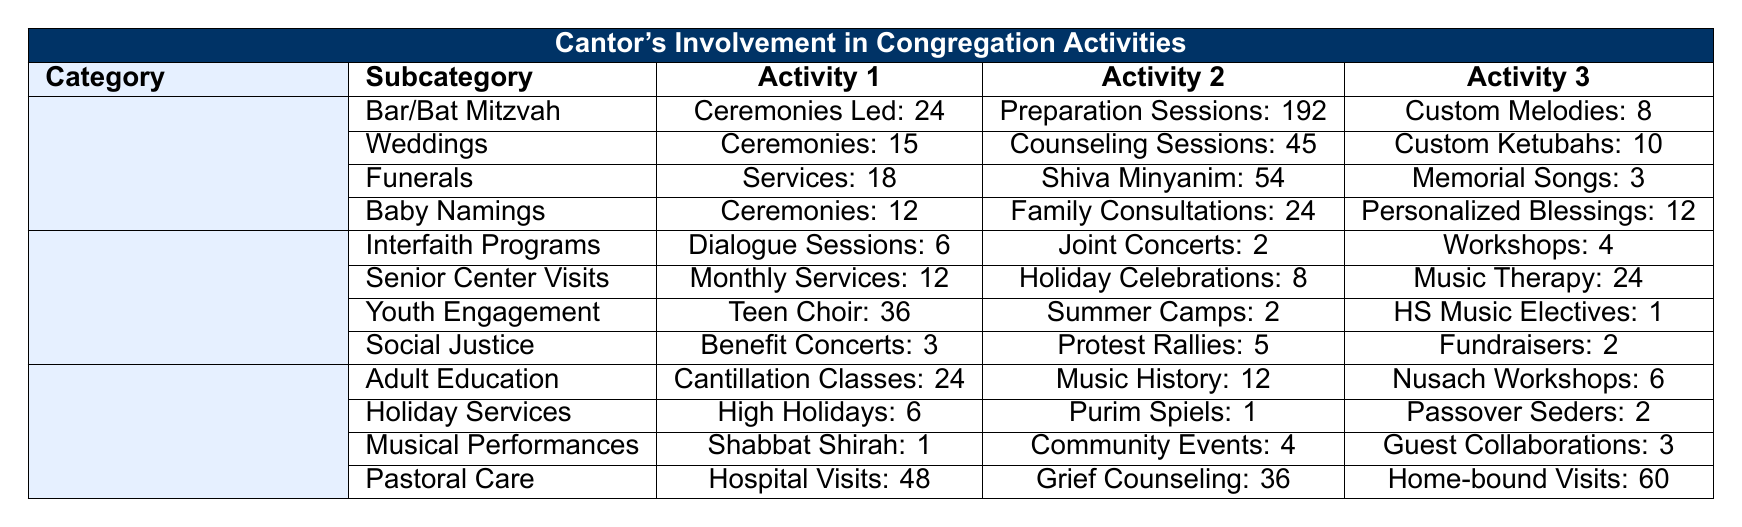What is the total number of Bar/Bat Mitzvah preparation sessions led by the cantor? The table states that there were 192 preparation sessions for Bar/Bat Mitzvah events.
Answer: 192 How many weddings did the cantor officiate in total? The table indicates that there were 15 weddings officiated by the cantor.
Answer: 15 What is the combined total of ceremonies performed among Baby Namings and Funerals? Baby Namings had 12 ceremonies performed and Funerals had 18 services conducted. Adding these gives us 12 + 18 = 30.
Answer: 30 How many music therapy sessions were conducted at senior centers? According to the table, there were 24 music therapy sessions conducted at senior centers.
Answer: 24 What is the average number of ceremonies led per lifecycle event category? There are 4 lifecycle event categories and the total number of ceremonies led in Bar/Bat Mitzvah (24) + Weddings (15) + Funerals (18) + Baby Namings (12) leads to a total of 69. Dividing 69 by 4 gives an average of 17.25.
Answer: 17.25 Did the cantor lead more dialogue sessions or music therapy sessions? The cantor led 6 dialogue sessions in Interfaith Programs and 24 music therapy sessions at the Senior Center Visits. Since 24 is greater than 6, the cantor led more music therapy sessions.
Answer: Yes What is the total number of community outreach activities listed in the table? The categories include Interfaith Programs (6 + 2 + 4), Senior Center Visits (12 + 8 + 24), Youth Engagement (36 + 2 + 1), and Social Justice Initiatives (3 + 5 + 2). The sums are 12, 44, 39, and 10, respectively. Adding these totals gives us 12 + 44 + 39 + 10 = 105.
Answer: 105 Which lifecycle event had the highest number of preparation sessions? The Life Cycle events listed show Bar/Bat Mitzvah has 192 preparation sessions, more than the others.
Answer: Bar/Bat Mitzvah How many occasions did the cantor participate in social justice initiatives? The total for social justice initiatives in the table notes 3 benefit concerts, 5 protest rallies, and 2 fundraisers, giving a total of 3 + 5 + 2 = 10 occasions.
Answer: 10 What proportion of the total activities in Synagogue Programs are related to Musical Performances? The total in Synagogue Programs is calculated by adding Adult Education (24 + 12 + 6 = 42), Holiday Services (6 + 1 + 2 = 9), Musical Performances (1 + 4 + 3 = 8), and Pastoral Care (48 + 36 + 60 = 144), totaling 42 + 9 + 8 + 144 = 203. The proportion attributable to musical performances is 8/203, which is approximately 0.0394 or 3.94%.
Answer: Approximately 3.94% What is the maximum number of ceremonies led by the cantor in a single lifecycle event type? The highest number of ceremonies is seen in Bar/Bat Mitzvah, where 24 ceremonies were led.
Answer: 24 